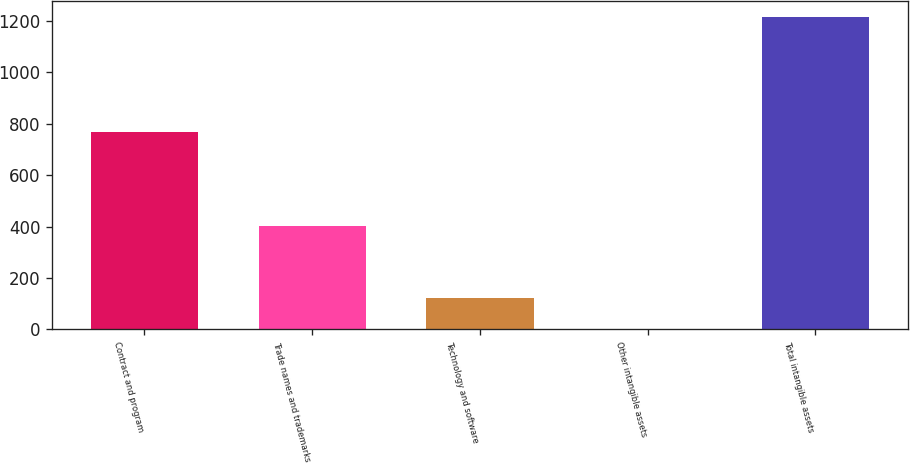Convert chart. <chart><loc_0><loc_0><loc_500><loc_500><bar_chart><fcel>Contract and program<fcel>Trade names and trademarks<fcel>Technology and software<fcel>Other intangible assets<fcel>Total intangible assets<nl><fcel>769<fcel>404<fcel>122.6<fcel>1<fcel>1217<nl></chart> 